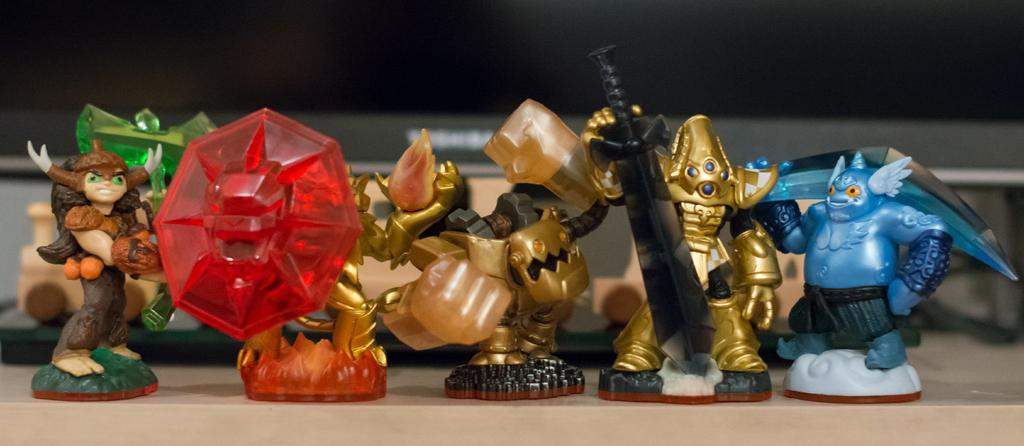What is placed on the floor in the image? There are different kinds of toys placed on the floor. Can you describe the types of toys present on the floor? Unfortunately, the provided facts do not specify the types of toys on the floor. Are there any other objects or figures accompanying the toys on the floor? The image only shows different kinds of toys placed on the floor. What type of ear can be seen attached to the steel instrument in the image? There is no ear or steel instrument present in the image; it features different kinds of toys placed on the floor. 